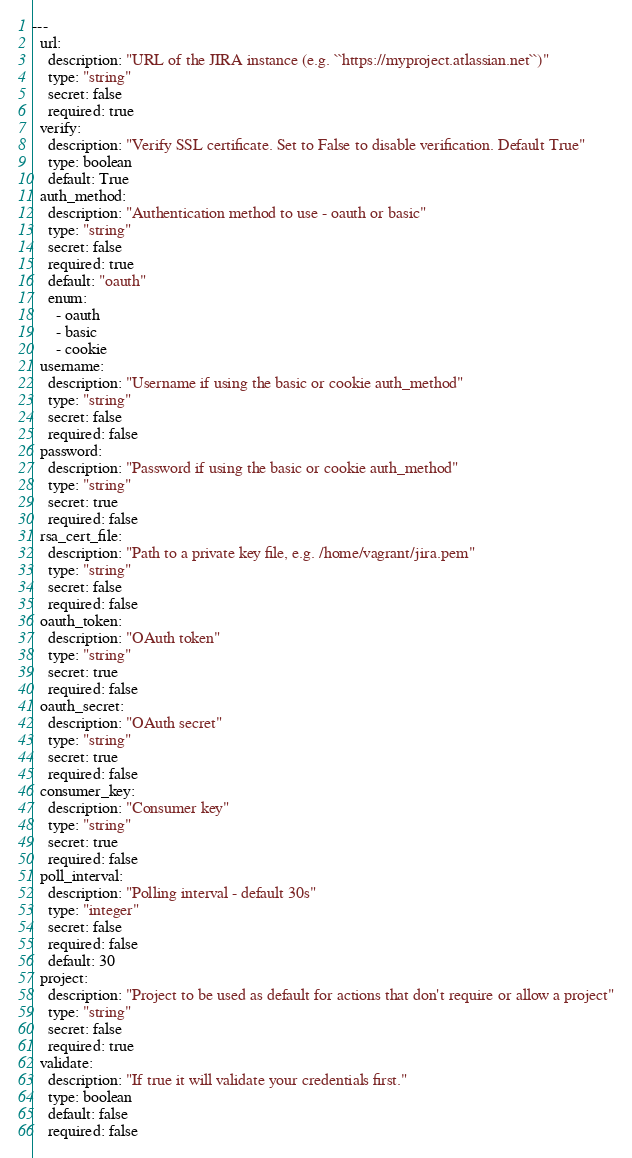Convert code to text. <code><loc_0><loc_0><loc_500><loc_500><_YAML_>---
  url:
    description: "URL of the JIRA instance (e.g. ``https://myproject.atlassian.net``)"
    type: "string"
    secret: false
    required: true
  verify:
    description: "Verify SSL certificate. Set to False to disable verification. Default True"
    type: boolean
    default: True
  auth_method:
    description: "Authentication method to use - oauth or basic"
    type: "string"
    secret: false
    required: true
    default: "oauth"
    enum:
      - oauth
      - basic
      - cookie
  username:
    description: "Username if using the basic or cookie auth_method"
    type: "string"
    secret: false
    required: false
  password:
    description: "Password if using the basic or cookie auth_method"
    type: "string"
    secret: true
    required: false
  rsa_cert_file:
    description: "Path to a private key file, e.g. /home/vagrant/jira.pem"
    type: "string"
    secret: false
    required: false
  oauth_token:
    description: "OAuth token"
    type: "string"
    secret: true
    required: false
  oauth_secret:
    description: "OAuth secret"
    type: "string"
    secret: true
    required: false
  consumer_key:
    description: "Consumer key"
    type: "string"
    secret: true
    required: false
  poll_interval:
    description: "Polling interval - default 30s"
    type: "integer"
    secret: false
    required: false
    default: 30
  project:
    description: "Project to be used as default for actions that don't require or allow a project"
    type: "string"
    secret: false
    required: true
  validate:
    description: "If true it will validate your credentials first."
    type: boolean
    default: false
    required: false
</code> 